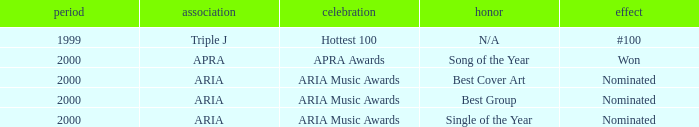Which award was nominated for in 2000? Best Cover Art, Best Group, Single of the Year. 